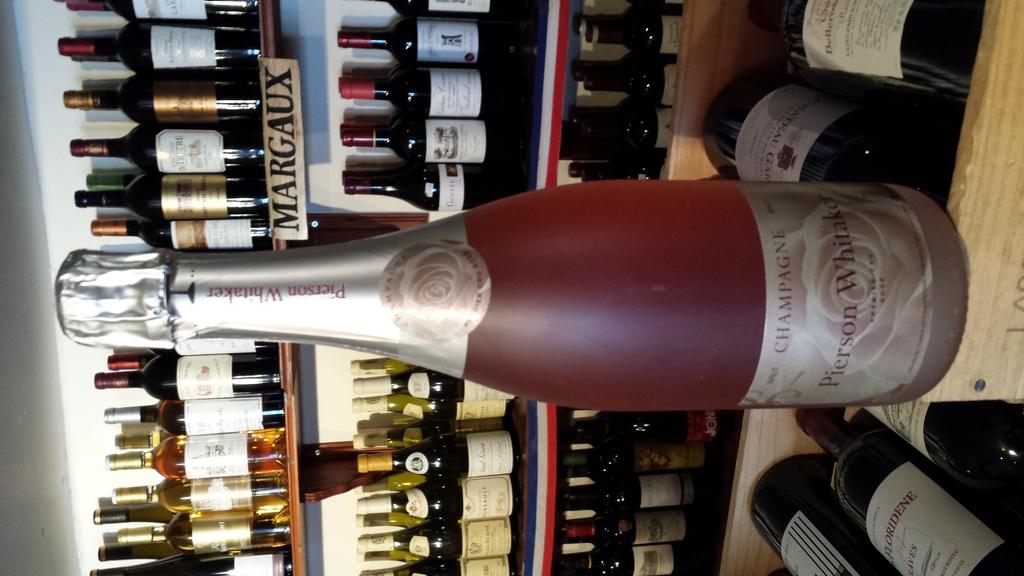What brand does the sign on the right advertise?
Provide a short and direct response. Margaux. 